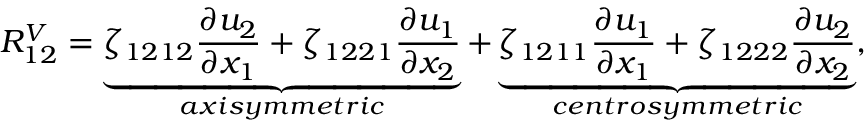<formula> <loc_0><loc_0><loc_500><loc_500>R _ { 1 2 } ^ { V } = \underbrace { \zeta _ { 1 2 1 2 } \frac { \partial u _ { 2 } } { \partial x _ { 1 } } + \zeta _ { 1 2 2 1 } \frac { \partial u _ { 1 } } { \partial x _ { 2 } } } _ { a x i s y m m e t r i c } + \underbrace { \zeta _ { 1 2 1 1 } \frac { \partial u _ { 1 } } { \partial x _ { 1 } } + \zeta _ { 1 2 2 2 } \frac { \partial u _ { 2 } } { \partial x _ { 2 } } } _ { c e n t r o s y m m e t r i c } ,</formula> 